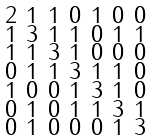Convert formula to latex. <formula><loc_0><loc_0><loc_500><loc_500>\begin{smallmatrix} 2 & 1 & 1 & 0 & 1 & 0 & 0 \\ 1 & 3 & 1 & 1 & 0 & 1 & 1 \\ 1 & 1 & 3 & 1 & 0 & 0 & 0 \\ 0 & 1 & 1 & 3 & 1 & 1 & 0 \\ 1 & 0 & 0 & 1 & 3 & 1 & 0 \\ 0 & 1 & 0 & 1 & 1 & 3 & 1 \\ 0 & 1 & 0 & 0 & 0 & 1 & 3 \end{smallmatrix}</formula> 